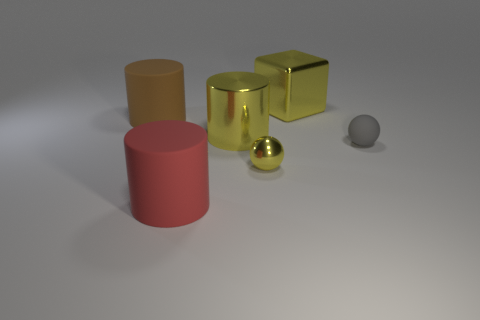Are there any other things that have the same size as the metal ball?
Provide a succinct answer. Yes. There is a metallic ball that is the same color as the metallic cylinder; what is its size?
Your answer should be compact. Small. What number of rubber things are to the right of the tiny yellow thing and left of the small matte sphere?
Make the answer very short. 0. What is the material of the large object in front of the gray rubber object?
Your response must be concise. Rubber. What size is the gray ball that is the same material as the brown thing?
Make the answer very short. Small. Are there any red things behind the small gray matte ball?
Provide a succinct answer. No. There is another metal object that is the same shape as the big red thing; what size is it?
Provide a short and direct response. Large. Is the color of the tiny metal thing the same as the big shiny object on the left side of the yellow block?
Your answer should be compact. Yes. Is the color of the block the same as the small matte object?
Your answer should be very brief. No. Is the number of spheres less than the number of metallic things?
Offer a very short reply. Yes. 